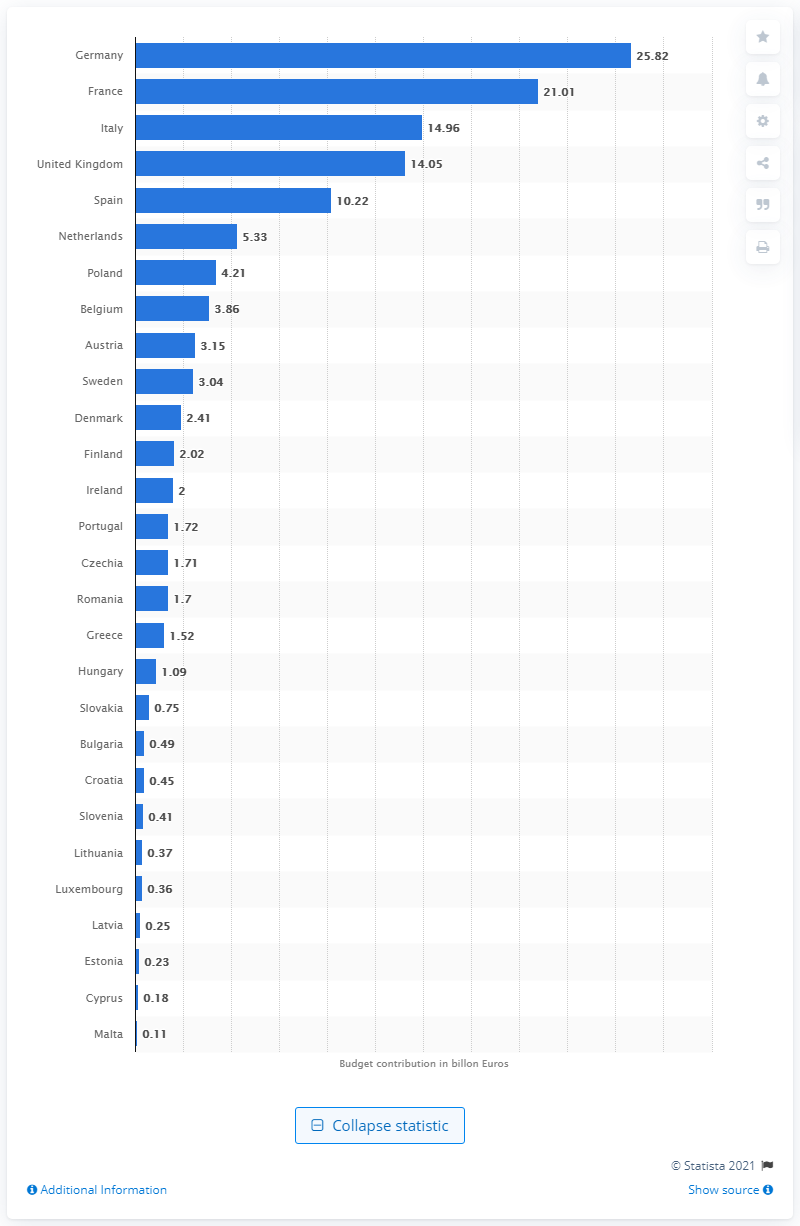Give some essential details in this illustration. The small island nation of Malta contributed the least amount to the budget of the European Union in 2019. The contribution of Germany to the budget of the European Union in 2019 was 25.82.. France contributed 21.01.2019 approximately how much to the budget of the European Union? The United Kingdom contributed 14.05% of the budget of the European Union in 2019. 